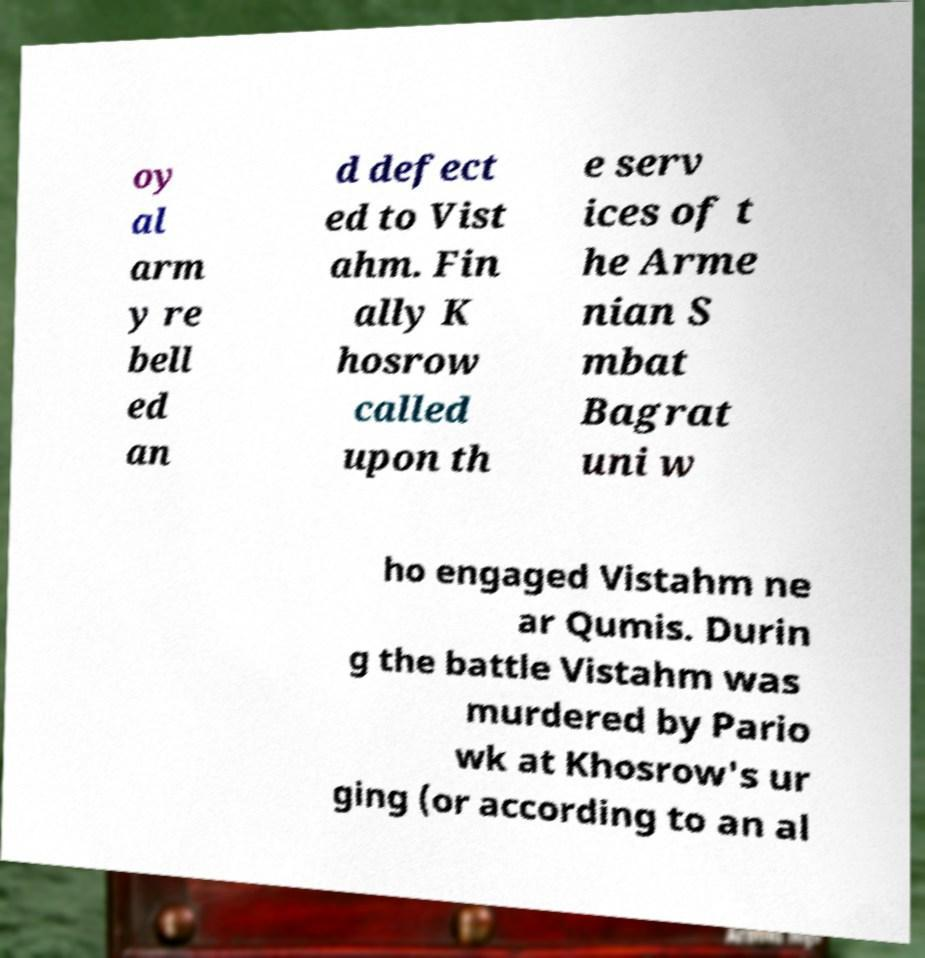For documentation purposes, I need the text within this image transcribed. Could you provide that? oy al arm y re bell ed an d defect ed to Vist ahm. Fin ally K hosrow called upon th e serv ices of t he Arme nian S mbat Bagrat uni w ho engaged Vistahm ne ar Qumis. Durin g the battle Vistahm was murdered by Pario wk at Khosrow's ur ging (or according to an al 